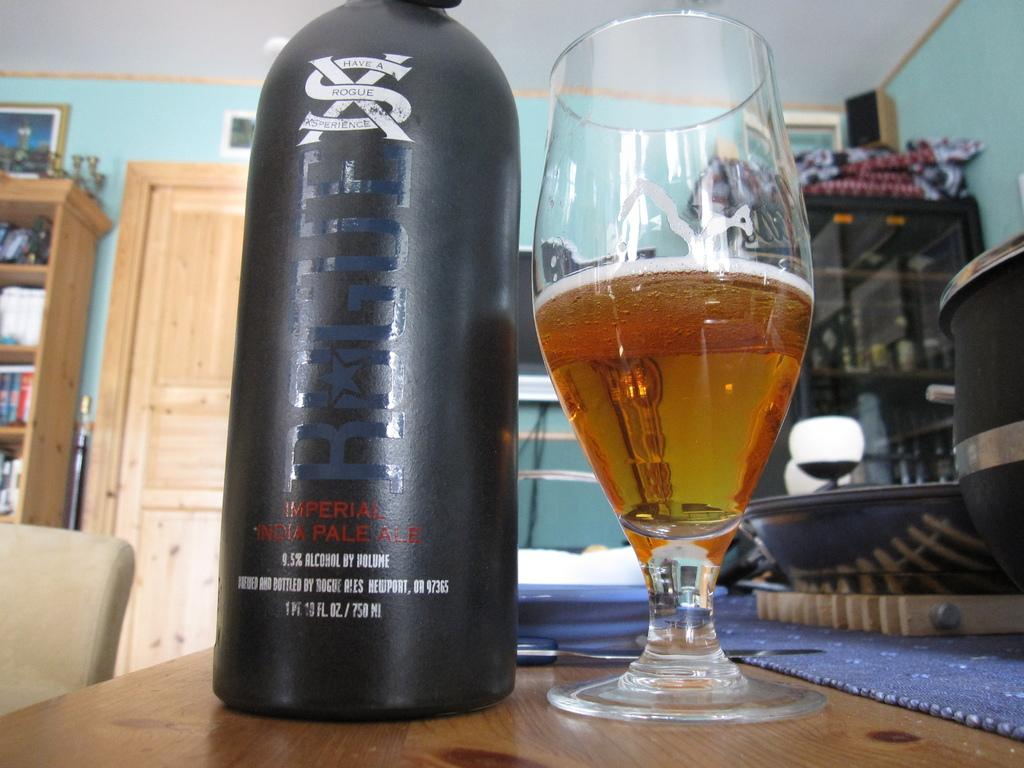<image>
Create a compact narrative representing the image presented. The drink here suggests that you should have a rogue experience. 